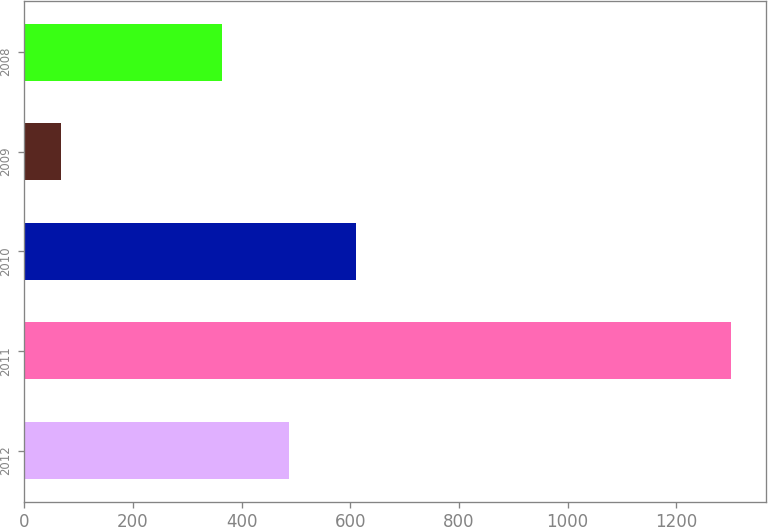<chart> <loc_0><loc_0><loc_500><loc_500><bar_chart><fcel>2012<fcel>2011<fcel>2010<fcel>2009<fcel>2008<nl><fcel>487.6<fcel>1300.4<fcel>610.9<fcel>67.4<fcel>364.3<nl></chart> 